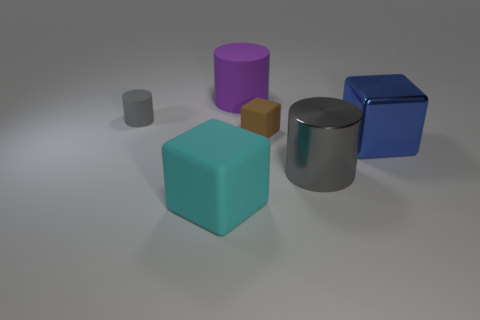Add 2 cyan cubes. How many objects exist? 8 Subtract all cubes. Subtract all big blue metallic cubes. How many objects are left? 2 Add 5 big metal blocks. How many big metal blocks are left? 6 Add 3 tiny red shiny things. How many tiny red shiny things exist? 3 Subtract 1 blue cubes. How many objects are left? 5 